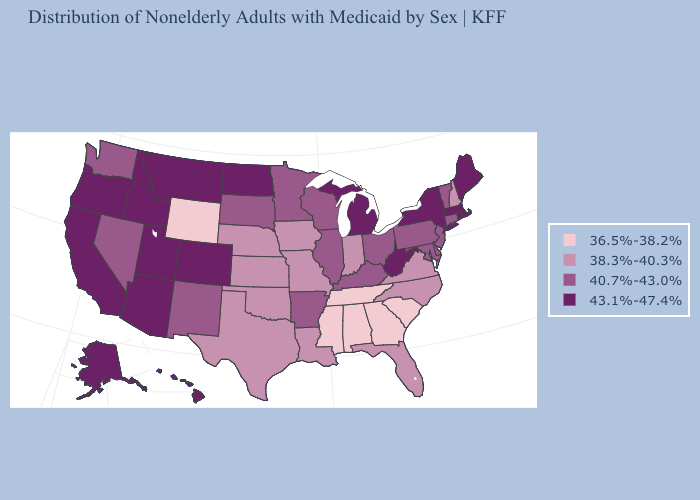Does West Virginia have the highest value in the USA?
Give a very brief answer. Yes. Which states have the lowest value in the USA?
Give a very brief answer. Alabama, Georgia, Mississippi, South Carolina, Tennessee, Wyoming. Does Iowa have the same value as North Carolina?
Quick response, please. Yes. Name the states that have a value in the range 43.1%-47.4%?
Write a very short answer. Alaska, Arizona, California, Colorado, Hawaii, Idaho, Maine, Massachusetts, Michigan, Montana, New York, North Dakota, Oregon, Rhode Island, Utah, West Virginia. What is the value of North Carolina?
Answer briefly. 38.3%-40.3%. Name the states that have a value in the range 43.1%-47.4%?
Concise answer only. Alaska, Arizona, California, Colorado, Hawaii, Idaho, Maine, Massachusetts, Michigan, Montana, New York, North Dakota, Oregon, Rhode Island, Utah, West Virginia. Among the states that border South Carolina , does Georgia have the highest value?
Answer briefly. No. What is the lowest value in the USA?
Write a very short answer. 36.5%-38.2%. What is the lowest value in the USA?
Short answer required. 36.5%-38.2%. Which states hav the highest value in the MidWest?
Write a very short answer. Michigan, North Dakota. Does South Carolina have a higher value than Alabama?
Answer briefly. No. What is the value of Nevada?
Give a very brief answer. 40.7%-43.0%. Which states have the lowest value in the MidWest?
Answer briefly. Indiana, Iowa, Kansas, Missouri, Nebraska. Which states have the lowest value in the South?
Answer briefly. Alabama, Georgia, Mississippi, South Carolina, Tennessee. 